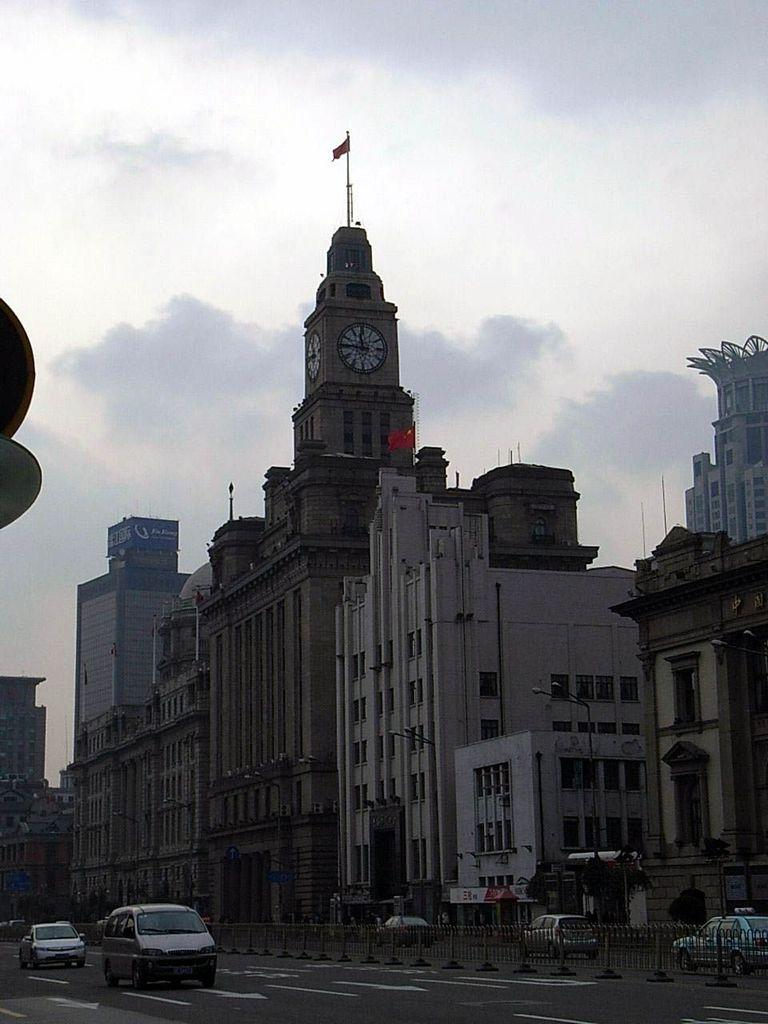What is located in the center of the image? There are buildings in the center of the image. What can be seen at the top of the image? The sky is visible at the top of the image. What is at the bottom of the image? There is a road at the bottom of the image. What is moving along the road in the image? Vehicles are present on the road. Can you tell me how many sisters are walking with a vegetable in the image? There are no sisters or vegetables present in the image. What type of shake is being prepared in the image? There is no shake being prepared in the image. 